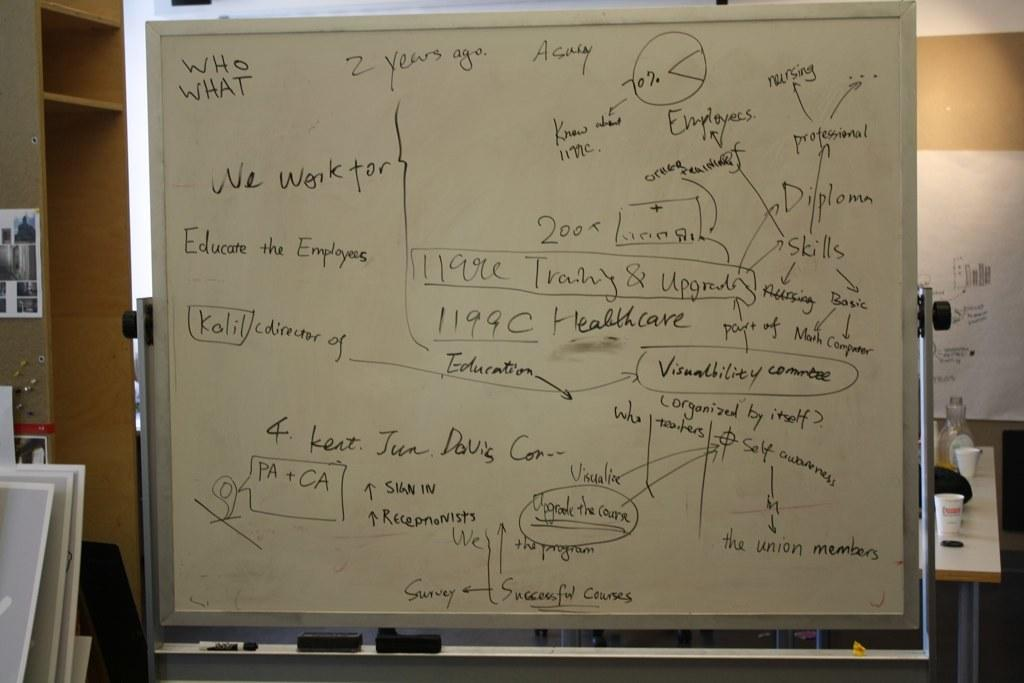What type of furniture is present in the image? There are shelves and a table in the image. What can be seen hanging on the wall in the image? There is a photo frame hanging on the wall in the image. What is the color of the wall in the image? The wall is white in color. What items are on the table in the image? There are glasses on the table in the image. Can you see an owl tied in a knot on the table in the image? No, there is no owl or knot present on the table in the image. 